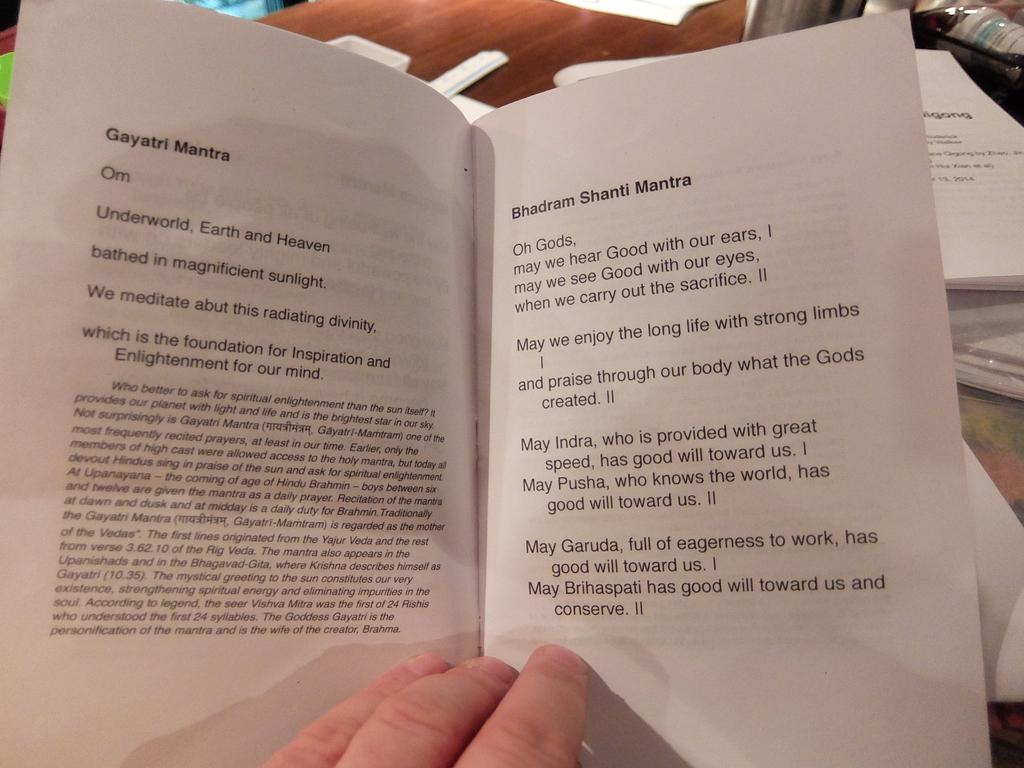Who is full of eagerness to work?
Give a very brief answer. Garuda. What is written in bold on the top of the left page?
Keep it short and to the point. Gayatri mantra. 